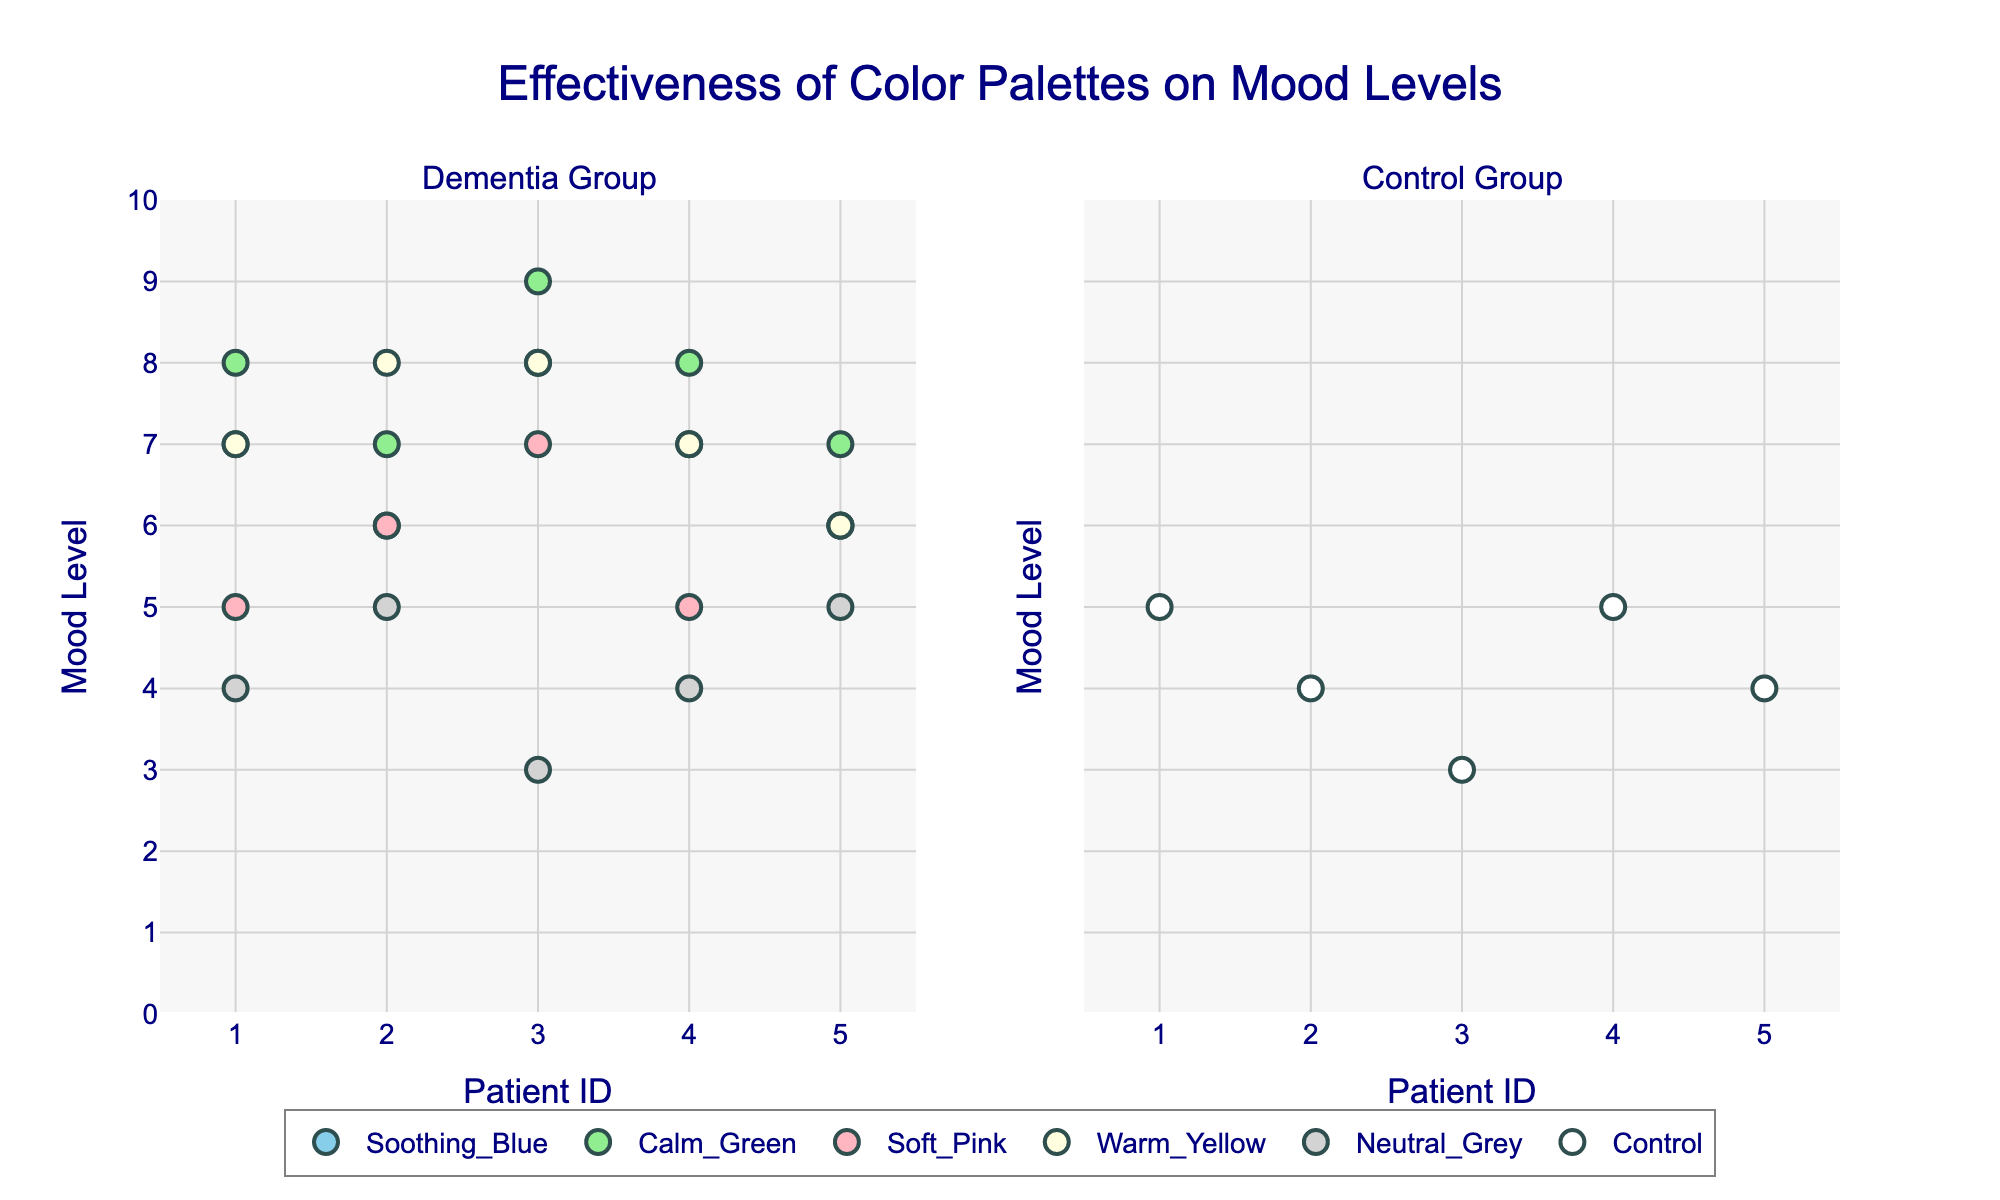What is the title of the plot? The title is prominently displayed at the top of the plot, reading: "Effectiveness of Color Palettes on Mood Levels".
Answer: Effectiveness of Color Palettes on Mood Levels What is the y-axis title? The y-axis title is shown along the vertical axis on both subplots. It reads: "Mood Level".
Answer: Mood Level How many color palettes are compared in the dementia group? Each unique point color in the left subplot indicates a different palette. The unique color labels in the legend show that there are five color palettes in the dementia group: Soothing_Blue, Calm_Green, Soft_Pink, Warm_Yellow, and Neutral_Grey.
Answer: 5 Which color palette shows the highest average mood level in the dementia group? First, identify the mood levels for each patient for all color palettes in the dementia group. Then, calculate the average mood levels. Calm_Green patients have mood levels: 8, 7, 9, 8, 7. The average is (8+7+9+8+7)/5 = 7.8. No other color palette has a higher average.
Answer: Calm_Green What is the range of mood levels in the control group? Examine the points in the right subplot (control group) to find the minimum and maximum mood levels. The minimum is 3 and the maximum is 5.
Answer: 3 to 5 Which color palette has the least variation in mood levels amongst dementia patients? Calculate the range for each palette in the dementia group. Soothing_Blue (max 8, min 6): range 2; Calm_Green (max 9, min 7): range 2; Soft_Pink (max 7, min 5): range 2; Warm_Yellow (max 8, min 6): range 2; Neutral_Grey (max 5, min 3): range 2. As all ranges are 2, each palette has equal variation.
Answer: Equal variation across all palettes Are there any mood levels shared by both dementia and control group patients? Observing the mood levels indicated by markers in both subplots, both groups have mood levels of 5 and 4.
Answer: Yes Which group has a higher maximum mood level? Compare the highest mood level points in the subplots. Dementia group has a maximum mood level of 9 (Calm_Green) while the Control group has a maximum of 5.
Answer: Dementia group How many patients are in each group? Count the number of unique patient markers in each subplot. Both subplots have patient IDs ranging from 1 to 5.
Answer: 5 Which color palette shows the most consistent mood level among dementia patients? Look for the palette with the smallest range or highest number of identical mood levels. Each dementia palette (Soothing_Blue, Calm_Green, Soft_Pink, Warm_Yellow, Neutral_Grey) shows exactly 2 units of variation, indicating the same consistency.
Answer: All equally consistent 